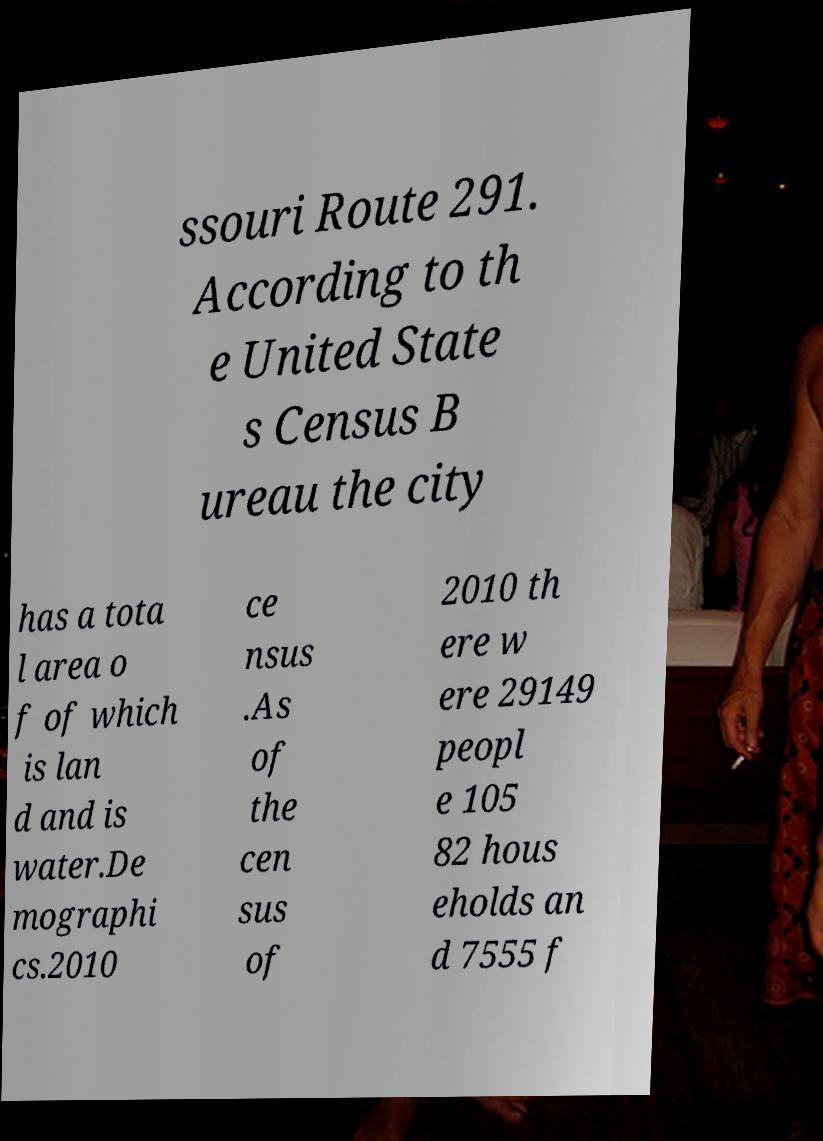Can you accurately transcribe the text from the provided image for me? ssouri Route 291. According to th e United State s Census B ureau the city has a tota l area o f of which is lan d and is water.De mographi cs.2010 ce nsus .As of the cen sus of 2010 th ere w ere 29149 peopl e 105 82 hous eholds an d 7555 f 